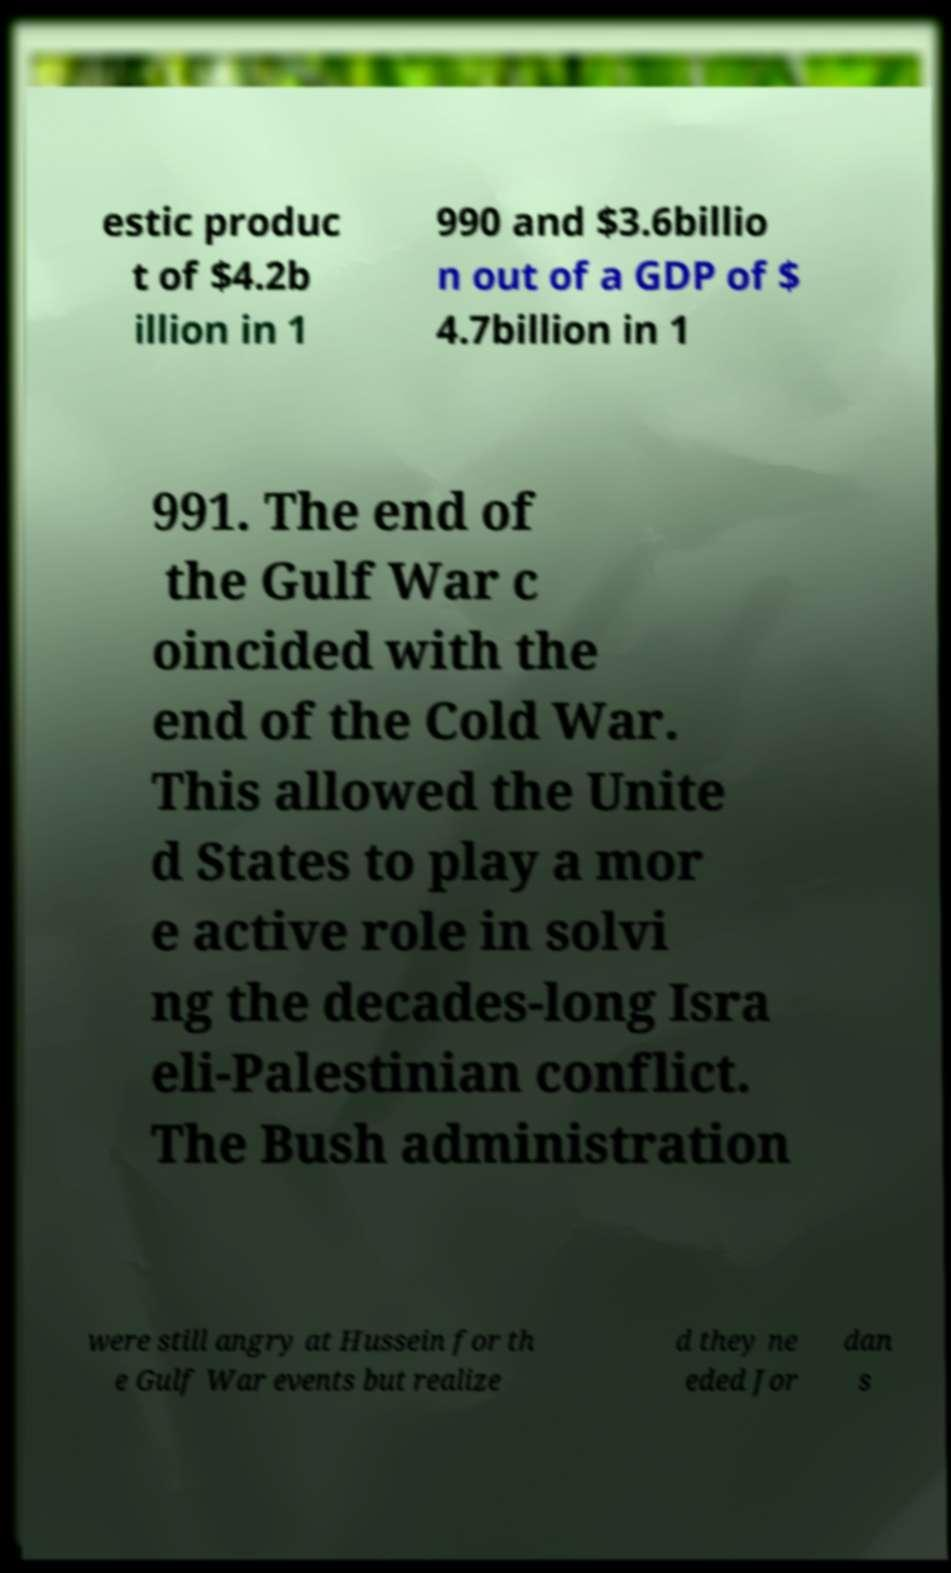Please identify and transcribe the text found in this image. estic produc t of $4.2b illion in 1 990 and $3.6billio n out of a GDP of $ 4.7billion in 1 991. The end of the Gulf War c oincided with the end of the Cold War. This allowed the Unite d States to play a mor e active role in solvi ng the decades-long Isra eli-Palestinian conflict. The Bush administration were still angry at Hussein for th e Gulf War events but realize d they ne eded Jor dan s 